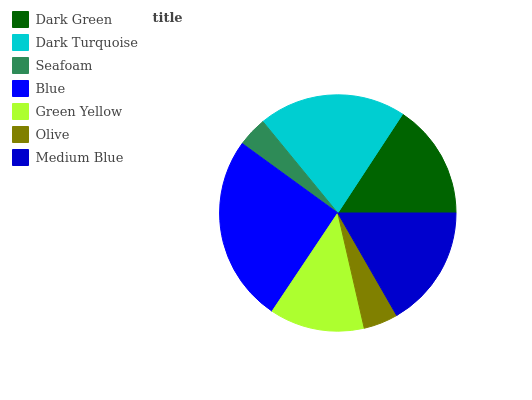Is Seafoam the minimum?
Answer yes or no. Yes. Is Blue the maximum?
Answer yes or no. Yes. Is Dark Turquoise the minimum?
Answer yes or no. No. Is Dark Turquoise the maximum?
Answer yes or no. No. Is Dark Turquoise greater than Dark Green?
Answer yes or no. Yes. Is Dark Green less than Dark Turquoise?
Answer yes or no. Yes. Is Dark Green greater than Dark Turquoise?
Answer yes or no. No. Is Dark Turquoise less than Dark Green?
Answer yes or no. No. Is Dark Green the high median?
Answer yes or no. Yes. Is Dark Green the low median?
Answer yes or no. Yes. Is Blue the high median?
Answer yes or no. No. Is Olive the low median?
Answer yes or no. No. 